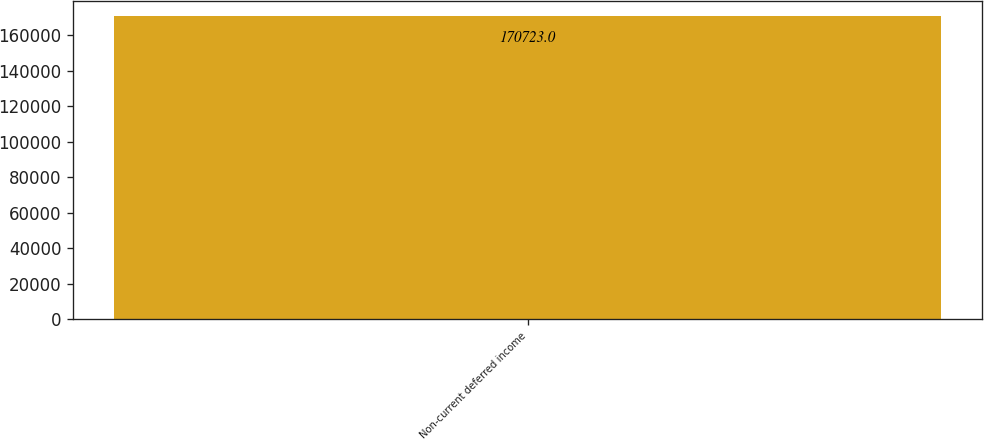<chart> <loc_0><loc_0><loc_500><loc_500><bar_chart><fcel>Non-current deferred income<nl><fcel>170723<nl></chart> 